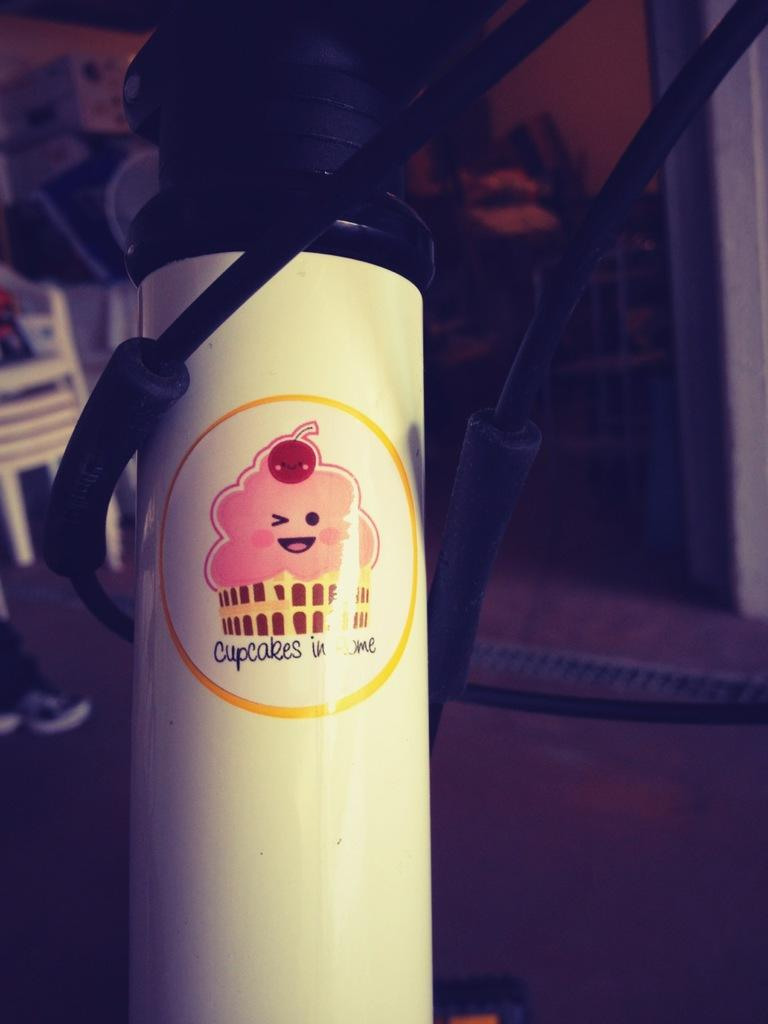<image>
Write a terse but informative summary of the picture. A white container has a picture of a cupcake and the word cupcake below it. 